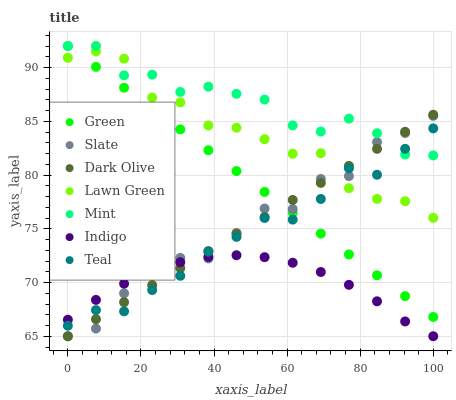Does Indigo have the minimum area under the curve?
Answer yes or no. Yes. Does Mint have the maximum area under the curve?
Answer yes or no. Yes. Does Slate have the minimum area under the curve?
Answer yes or no. No. Does Slate have the maximum area under the curve?
Answer yes or no. No. Is Dark Olive the smoothest?
Answer yes or no. Yes. Is Slate the roughest?
Answer yes or no. Yes. Is Indigo the smoothest?
Answer yes or no. No. Is Indigo the roughest?
Answer yes or no. No. Does Indigo have the lowest value?
Answer yes or no. Yes. Does Green have the lowest value?
Answer yes or no. No. Does Mint have the highest value?
Answer yes or no. Yes. Does Slate have the highest value?
Answer yes or no. No. Is Indigo less than Mint?
Answer yes or no. Yes. Is Green greater than Indigo?
Answer yes or no. Yes. Does Green intersect Mint?
Answer yes or no. Yes. Is Green less than Mint?
Answer yes or no. No. Is Green greater than Mint?
Answer yes or no. No. Does Indigo intersect Mint?
Answer yes or no. No. 